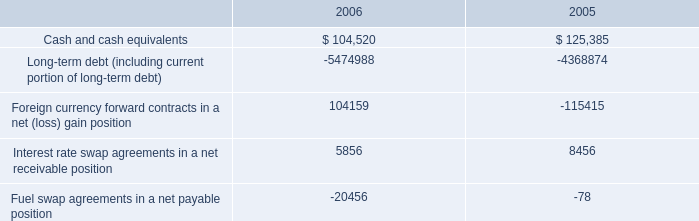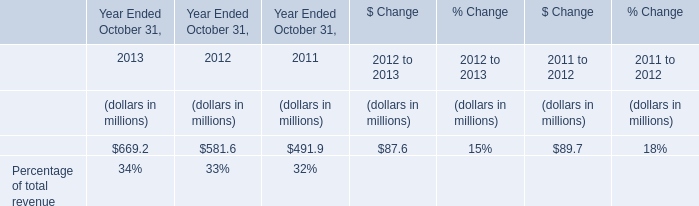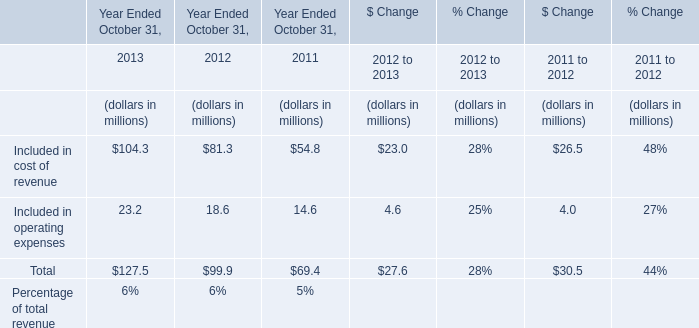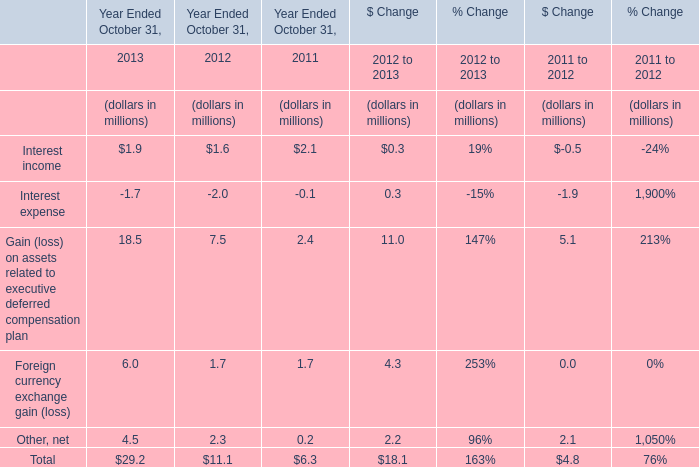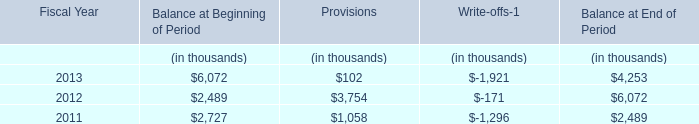what is the ratio of total cash to total long-term debt? 
Computations: ((104520 + 125385) / (5474988 + 4368874))
Answer: 0.02336. 